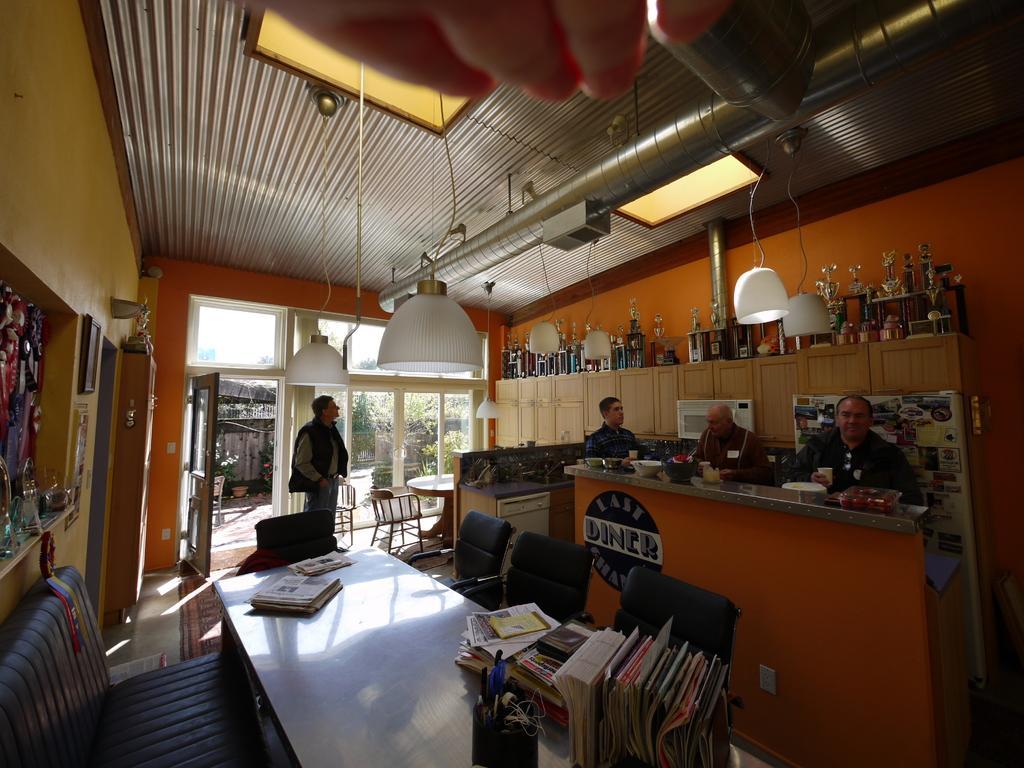In one or two sentences, can you explain what this image depicts? In this image we can see some people on the floor. We can also see some objects and books on the tables, a group of chairs, a sofa, the mementos and some objects placed on the cupboards, windows, a door, some plants and a roof with some ceiling lights. On the top of the image we can see the fingers of a person. 